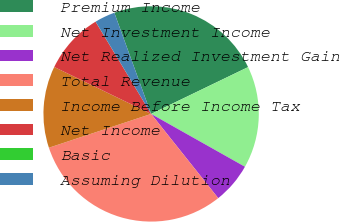Convert chart to OTSL. <chart><loc_0><loc_0><loc_500><loc_500><pie_chart><fcel>Premium Income<fcel>Net Investment Income<fcel>Net Realized Investment Gain<fcel>Total Revenue<fcel>Income Before Income Tax<fcel>Net Income<fcel>Basic<fcel>Assuming Dilution<nl><fcel>23.39%<fcel>15.32%<fcel>6.13%<fcel>30.62%<fcel>12.26%<fcel>9.19%<fcel>0.01%<fcel>3.07%<nl></chart> 